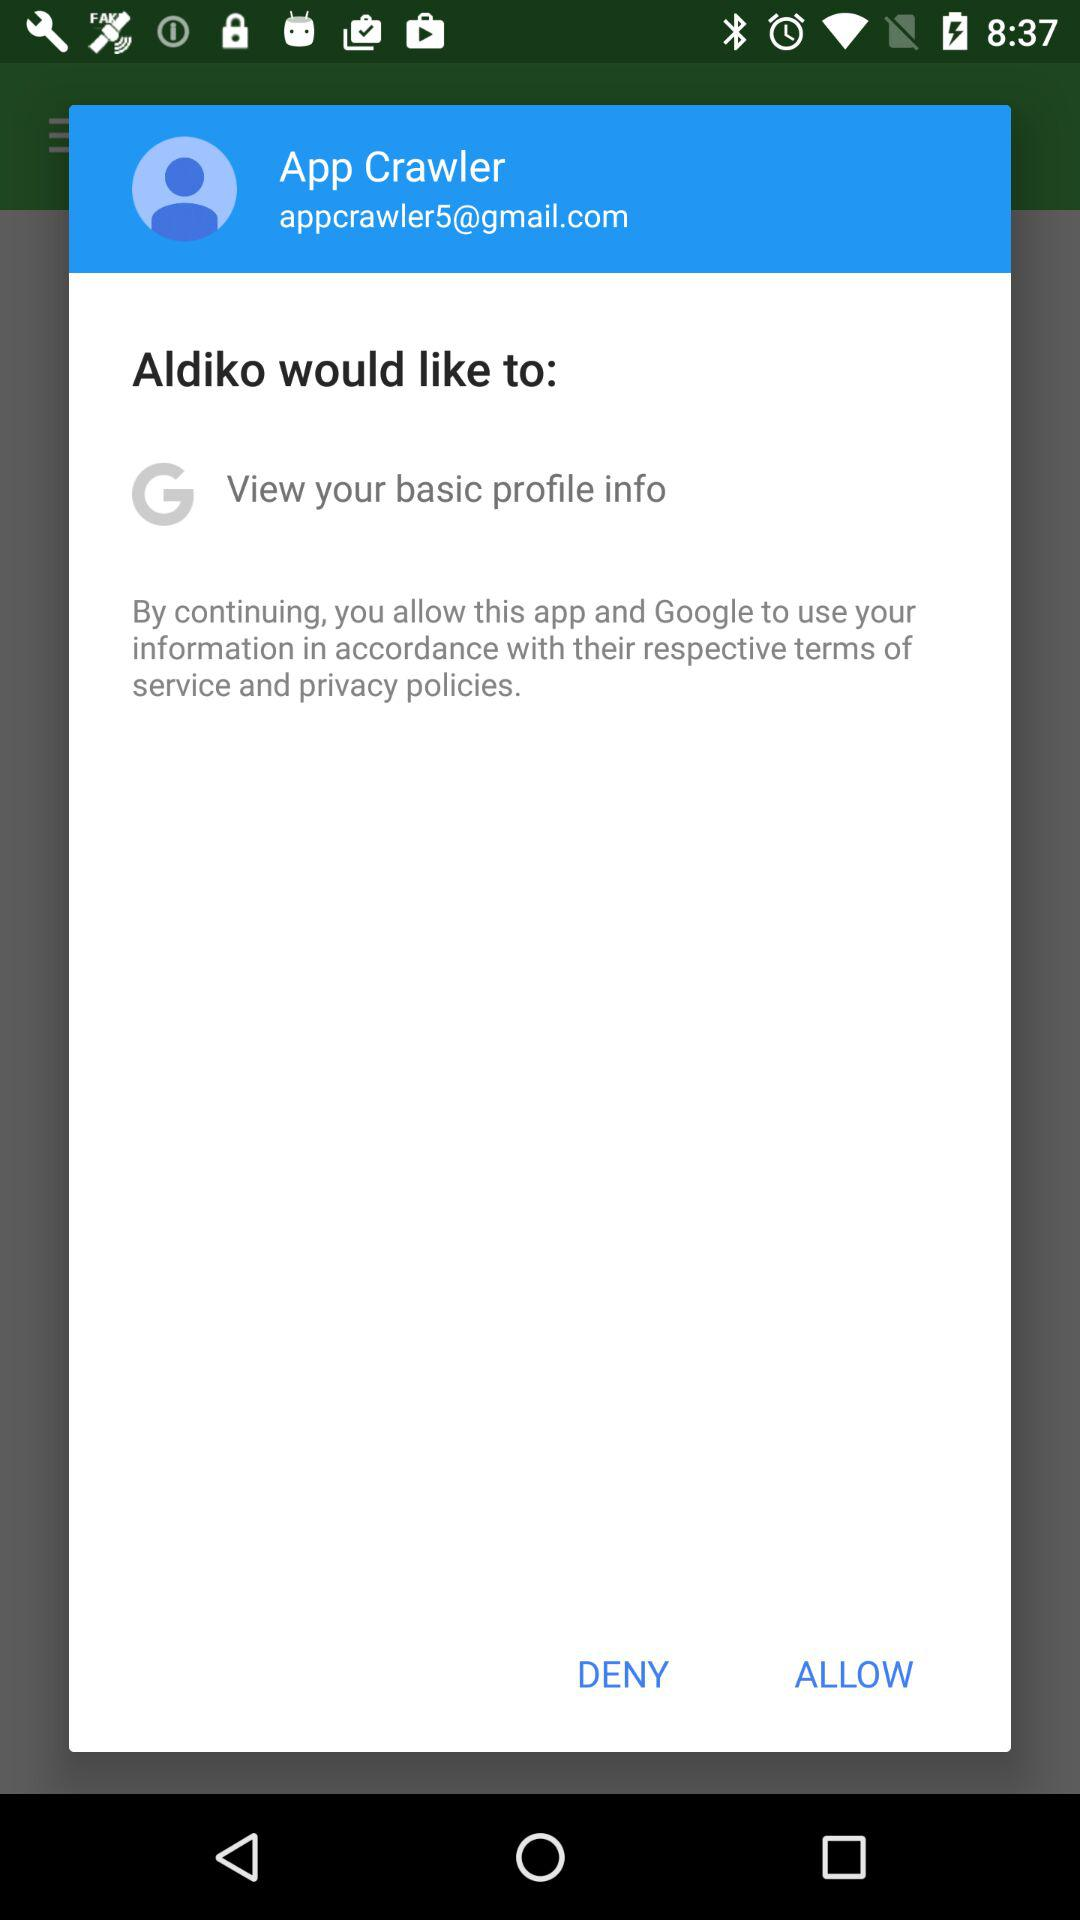What is the name of the person? The name of the person is App Crawler. 